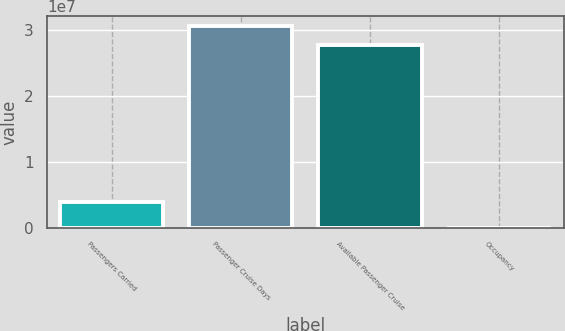Convert chart. <chart><loc_0><loc_0><loc_500><loc_500><bar_chart><fcel>Passengers Carried<fcel>Passenger Cruise Days<fcel>Available Passenger Cruise<fcel>Occupancy<nl><fcel>3.97028e+06<fcel>3.06715e+07<fcel>2.78212e+07<fcel>102.5<nl></chart> 